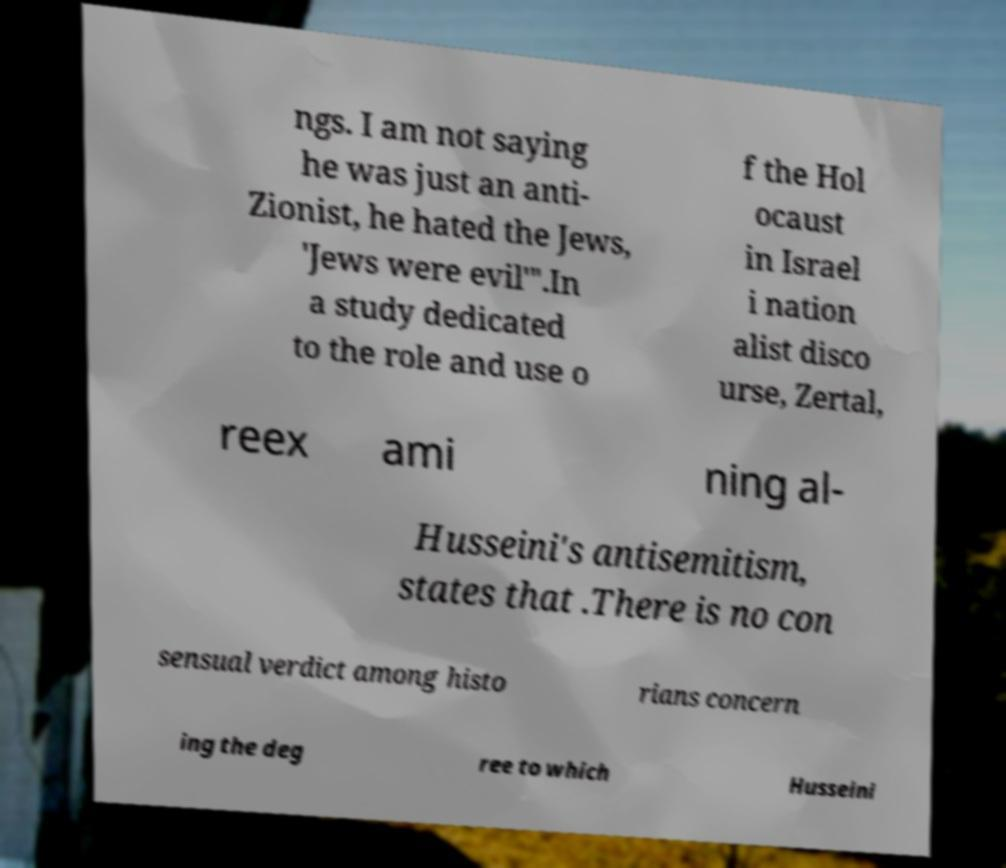Could you extract and type out the text from this image? ngs. I am not saying he was just an anti- Zionist, he hated the Jews, 'Jews were evil'".In a study dedicated to the role and use o f the Hol ocaust in Israel i nation alist disco urse, Zertal, reex ami ning al- Husseini's antisemitism, states that .There is no con sensual verdict among histo rians concern ing the deg ree to which Husseini 